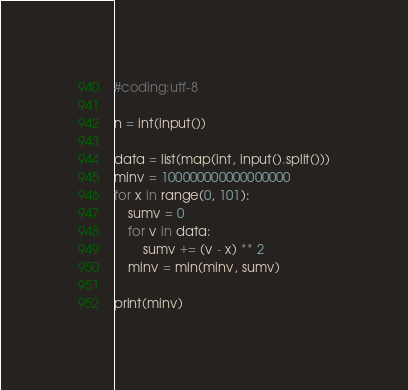<code> <loc_0><loc_0><loc_500><loc_500><_Python_>#coding:utf-8

n = int(input())

data = list(map(int, input().split()))
minv = 100000000000000000
for x in range(0, 101):
    sumv = 0
    for v in data:
        sumv += (v - x) ** 2
    minv = min(minv, sumv)
    
print(minv)</code> 